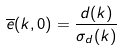Convert formula to latex. <formula><loc_0><loc_0><loc_500><loc_500>\overline { e } ( k , 0 ) = \frac { d ( k ) } { \sigma _ { d } ( k ) }</formula> 